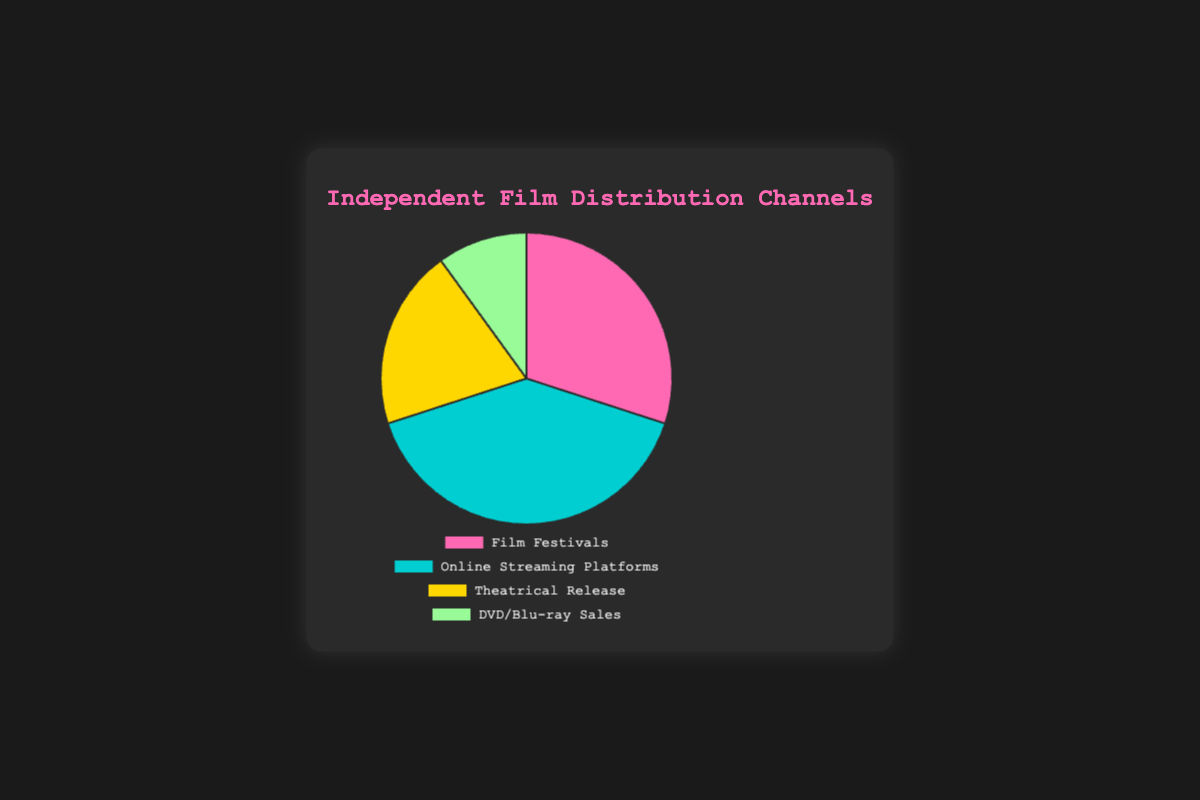Which distribution channel has the largest share? By looking at the pie chart and comparing the sections, Online Streaming Platforms have the largest share.
Answer: Online Streaming Platforms Which channel has the smallest percentage share? By examining the pie chart, the smallest section corresponds to DVD/Blu-ray Sales.
Answer: DVD/Blu-ray Sales What is the combined percentage share of Film Festivals and Theatrical Release? Find the percentages for Film Festivals and Theatrical Release in the chart: 30% and 20%. Add them together: 30% + 20% = 50%.
Answer: 50% How much larger is the share of Online Streaming Platforms compared to Theatrical Release? Subtract the percentage of Theatrical Release from Online Streaming Platforms: 40% - 20% = 20%.
Answer: 20% If DVD/Blu-ray Sales doubled their share, what would the new percentage be? Calculate twice the current percentage of DVD/Blu-ray Sales: 10% * 2 = 20%.
Answer: 20% Which channel is represented by the pink color? By identifying the colors in the pie chart, the pink section corresponds to Film Festivals.
Answer: Film Festivals Which channels have a combined share equal to the share of Online Streaming Platforms? Check the chart for channels with combined shares adding up to 40%. Film Festivals (30%) and DVD/Blu-ray Sales (10%) together make 40%.
Answer: Film Festivals and DVD/Blu-ray Sales Which two distribution channels together make up more than half of the total share? By adding the two largest shares: Online Streaming Platforms (40%) and Film Festivals (30%), together they make up 70%, which is more than 50%.
Answer: Online Streaming Platforms and Film Festivals 